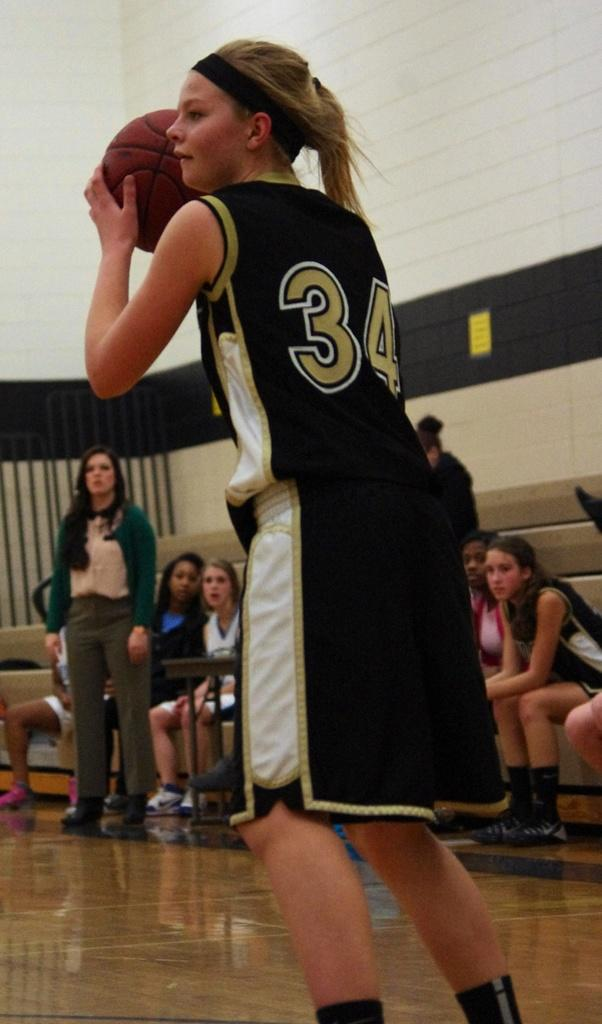<image>
Relay a brief, clear account of the picture shown. A basket ball player has the ball with a number 34 on her jersey 